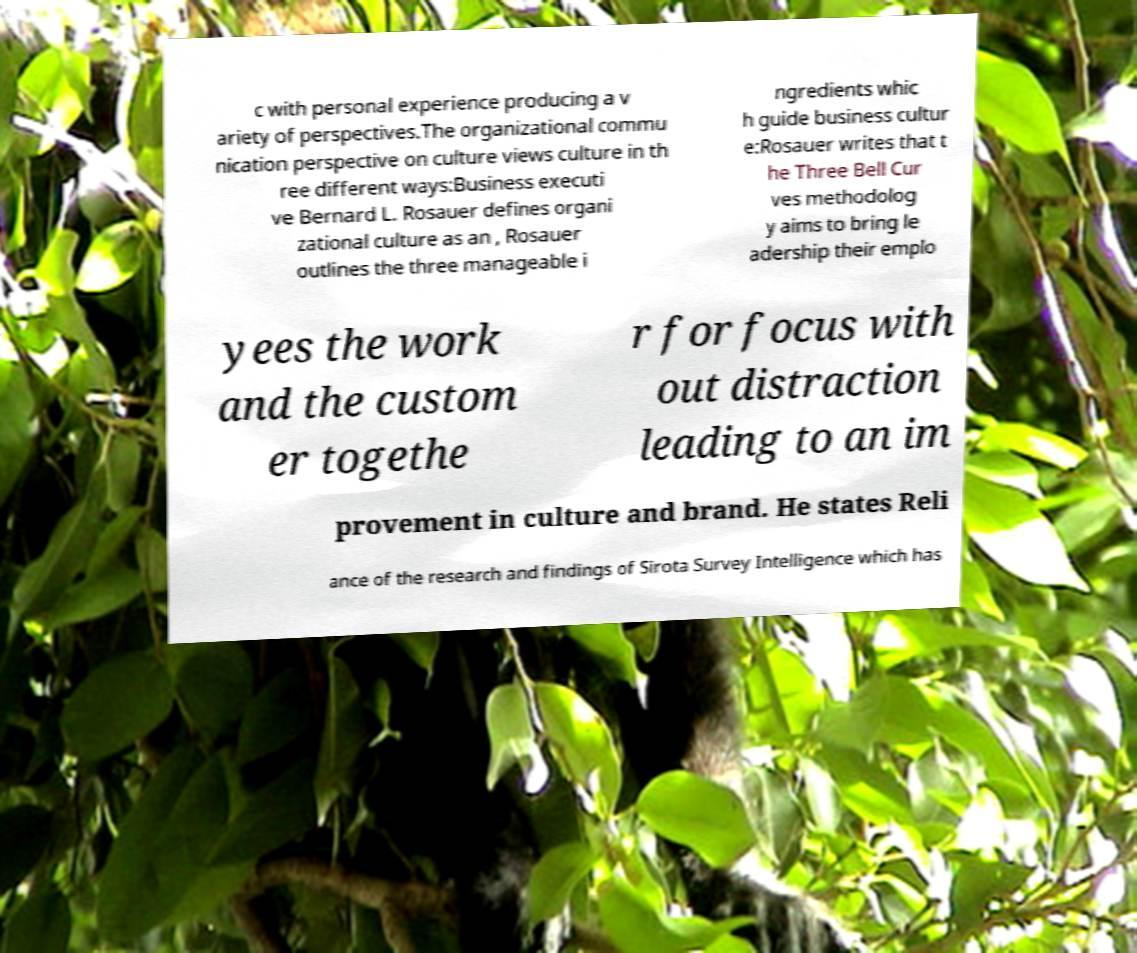Could you assist in decoding the text presented in this image and type it out clearly? c with personal experience producing a v ariety of perspectives.The organizational commu nication perspective on culture views culture in th ree different ways:Business executi ve Bernard L. Rosauer defines organi zational culture as an , Rosauer outlines the three manageable i ngredients whic h guide business cultur e:Rosauer writes that t he Three Bell Cur ves methodolog y aims to bring le adership their emplo yees the work and the custom er togethe r for focus with out distraction leading to an im provement in culture and brand. He states Reli ance of the research and findings of Sirota Survey Intelligence which has 